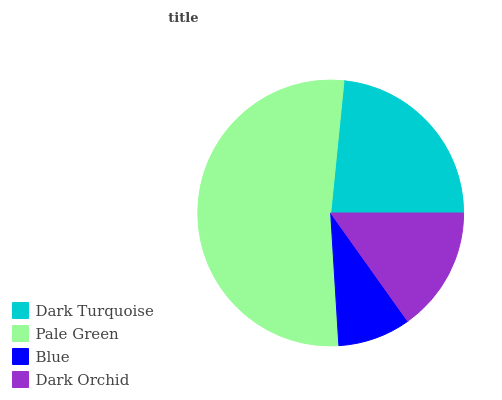Is Blue the minimum?
Answer yes or no. Yes. Is Pale Green the maximum?
Answer yes or no. Yes. Is Pale Green the minimum?
Answer yes or no. No. Is Blue the maximum?
Answer yes or no. No. Is Pale Green greater than Blue?
Answer yes or no. Yes. Is Blue less than Pale Green?
Answer yes or no. Yes. Is Blue greater than Pale Green?
Answer yes or no. No. Is Pale Green less than Blue?
Answer yes or no. No. Is Dark Turquoise the high median?
Answer yes or no. Yes. Is Dark Orchid the low median?
Answer yes or no. Yes. Is Blue the high median?
Answer yes or no. No. Is Pale Green the low median?
Answer yes or no. No. 